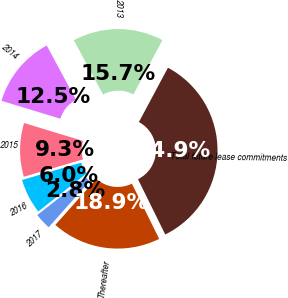Convert chart. <chart><loc_0><loc_0><loc_500><loc_500><pie_chart><fcel>2013<fcel>2014<fcel>2015<fcel>2016<fcel>2017<fcel>Thereafter<fcel>Total future lease commitments<nl><fcel>15.66%<fcel>12.45%<fcel>9.25%<fcel>6.04%<fcel>2.84%<fcel>18.86%<fcel>34.89%<nl></chart> 